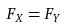Convert formula to latex. <formula><loc_0><loc_0><loc_500><loc_500>F _ { X } = F _ { Y }</formula> 